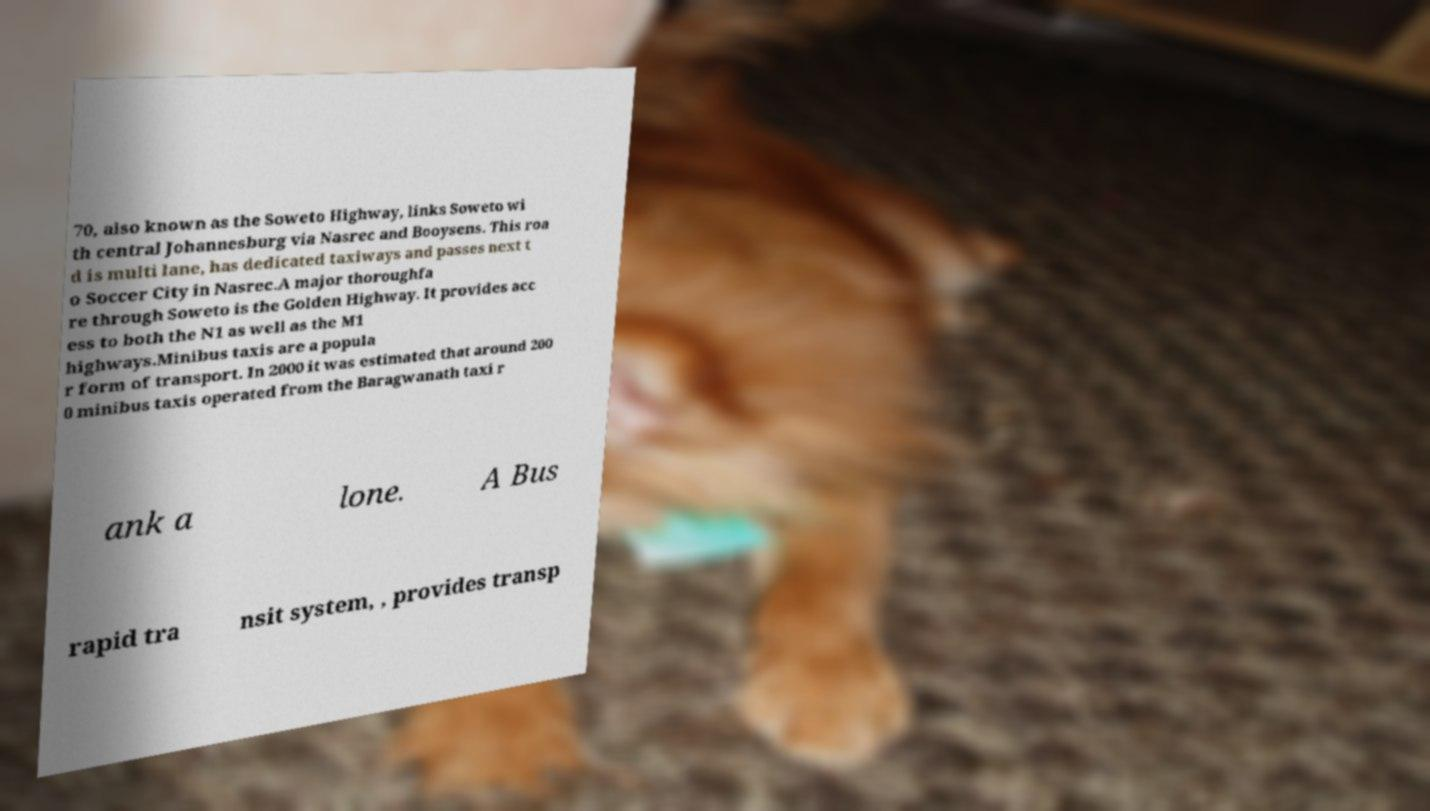Could you extract and type out the text from this image? 70, also known as the Soweto Highway, links Soweto wi th central Johannesburg via Nasrec and Booysens. This roa d is multi lane, has dedicated taxiways and passes next t o Soccer City in Nasrec.A major thoroughfa re through Soweto is the Golden Highway. It provides acc ess to both the N1 as well as the M1 highways.Minibus taxis are a popula r form of transport. In 2000 it was estimated that around 200 0 minibus taxis operated from the Baragwanath taxi r ank a lone. A Bus rapid tra nsit system, , provides transp 